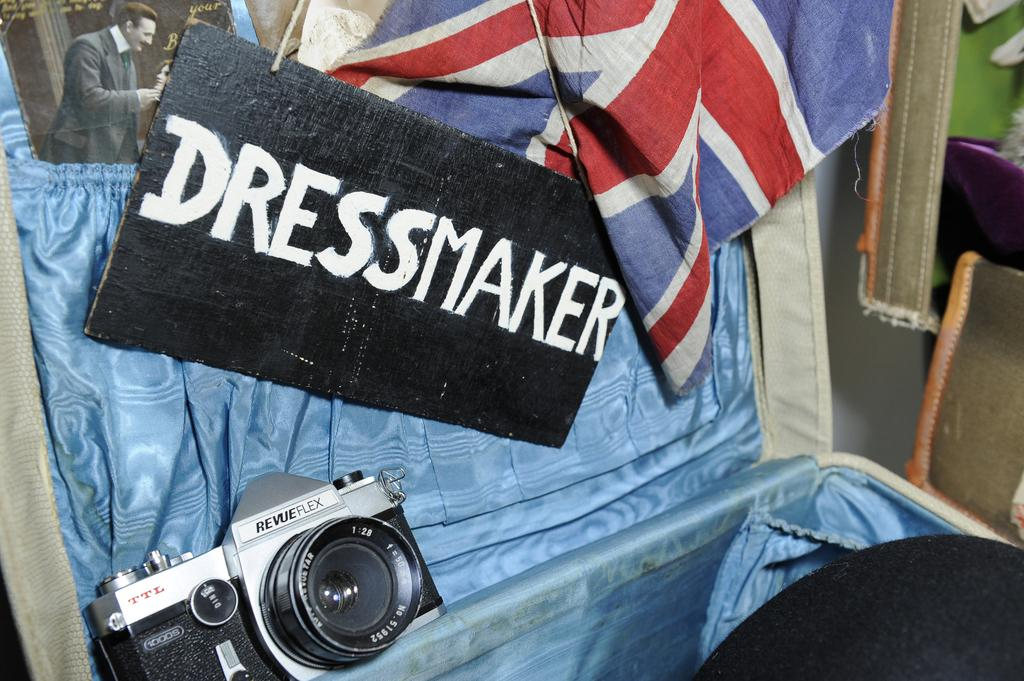What type of objects can be seen in the image? There are clothes, a camera, a board, and a picture in the image. What might be used for capturing images in the image? There is a camera in the image that can be used for capturing images. What is the purpose of the board in the image? The purpose of the board in the image is not explicitly stated, but it could be used for displaying or organizing items. What is depicted in the picture in the image? The content of the picture in the image is not specified, but it is present. How does the force of gravity affect the clothes in the image? The force of gravity affects the clothes in the image in the same way it affects all objects on Earth, by pulling them downward. However, the image does not provide any specific information about how the clothes are arranged or positioned, so we cannot determine the exact effect of gravity on them in this context. 